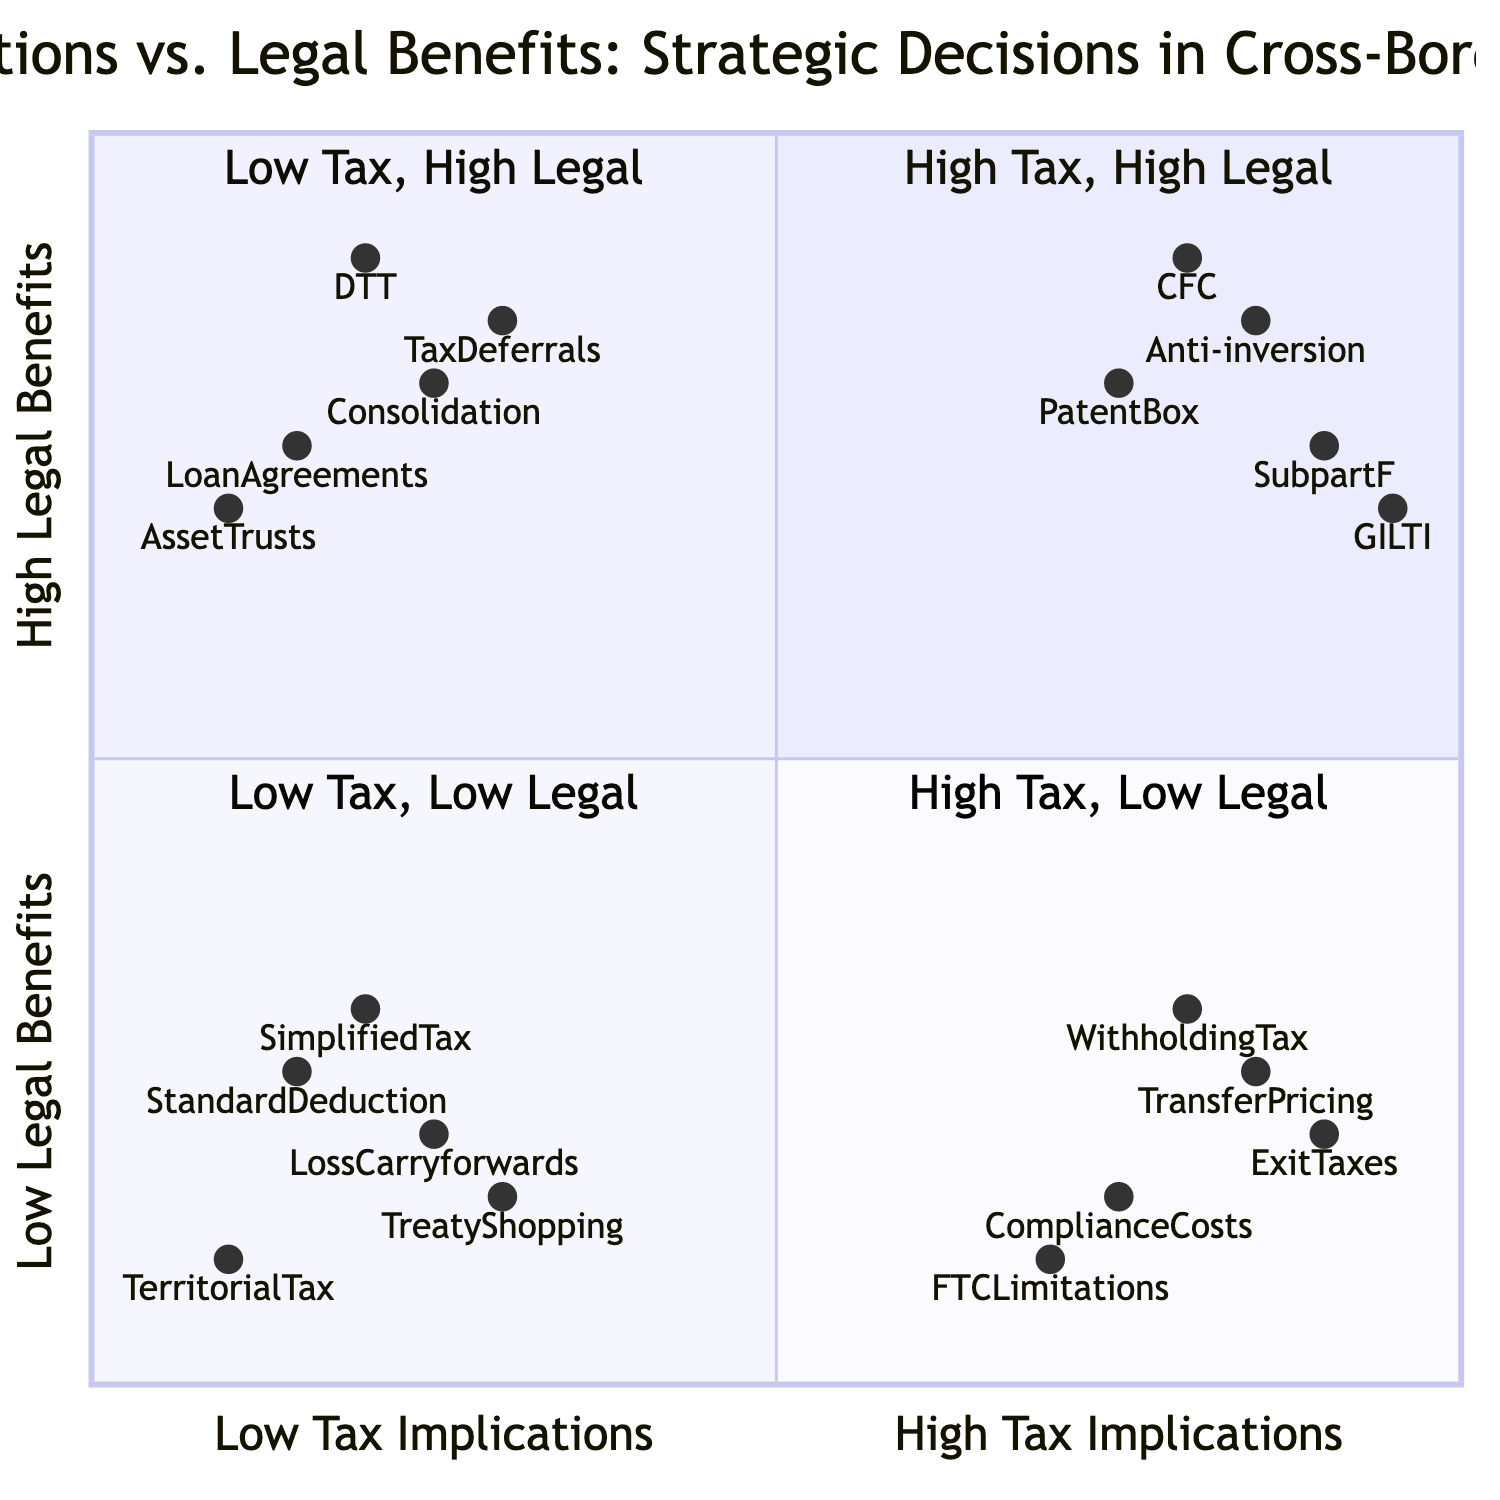What are the elements in the "High Tax Implications, High Legal Benefits" quadrant? To find the elements in this quadrant, I look at the quadrant labeled "High Tax Implications, High Legal Benefits." The elements listed under this quadrant are: Controlled Foreign Corporation (CFC) Regulations, Anti-inversion Rules, Patent Box Regimes, Subpart F Income, and Global Intangible Low-taxed Income (GILTI).
Answer: Controlled Foreign Corporation Regulations, Anti-inversion Rules, Patent Box Regimes, Subpart F Income, Global Intangible Low-taxed Income Which element has the highest legal benefits and exists in the "Low Tax Implications, High Legal Benefits" quadrant? I check the quadrant titled "Low Tax Implications, High Legal Benefits." The element with the highest position, which indicates the highest legal benefits in this quadrant, is Double Taxation Treaties, as it has the highest y-axis value.
Answer: Double Taxation Treaties What is the lowest legal benefit in the "High Tax Implications, Low Legal Benefits" quadrant? In the quadrant titled "High Tax Implications, Low Legal Benefits," I identify the element with the lowest position on the y-axis, which represents legal benefits. The element Transfer Pricing Adjustments has the lowest legal benefit level.
Answer: Transfer Pricing Adjustments How many elements are there in the "Low Tax Implications, Low Legal Benefits" quadrant? To find the number of elements in the quadrant "Low Tax Implications, Low Legal Benefits," I count the listed elements: Simplified Tax Regimes, Standard Deduction Allowances, Operating Loss Carryforwards, Treaty-shopping Restrictions, and Territorial Tax Systems. There are five elements in total.
Answer: Five Which quadrant contains the element "Exit Taxes"? I analyze the position of Exit Taxes, which is present in the downward section of the diagram with high tax implications and low legal benefits. Therefore, Exit Taxes are in the quadrant labeled "High Tax, Low Legal."
Answer: High Tax, Low Legal 